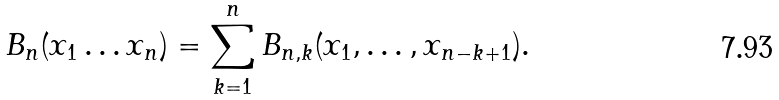Convert formula to latex. <formula><loc_0><loc_0><loc_500><loc_500>B _ { n } ( x _ { 1 } \dots x _ { n } ) & = \sum _ { k = 1 } ^ { n } B _ { n , k } ( x _ { 1 } , \dots , x _ { n - k + 1 } ) .</formula> 